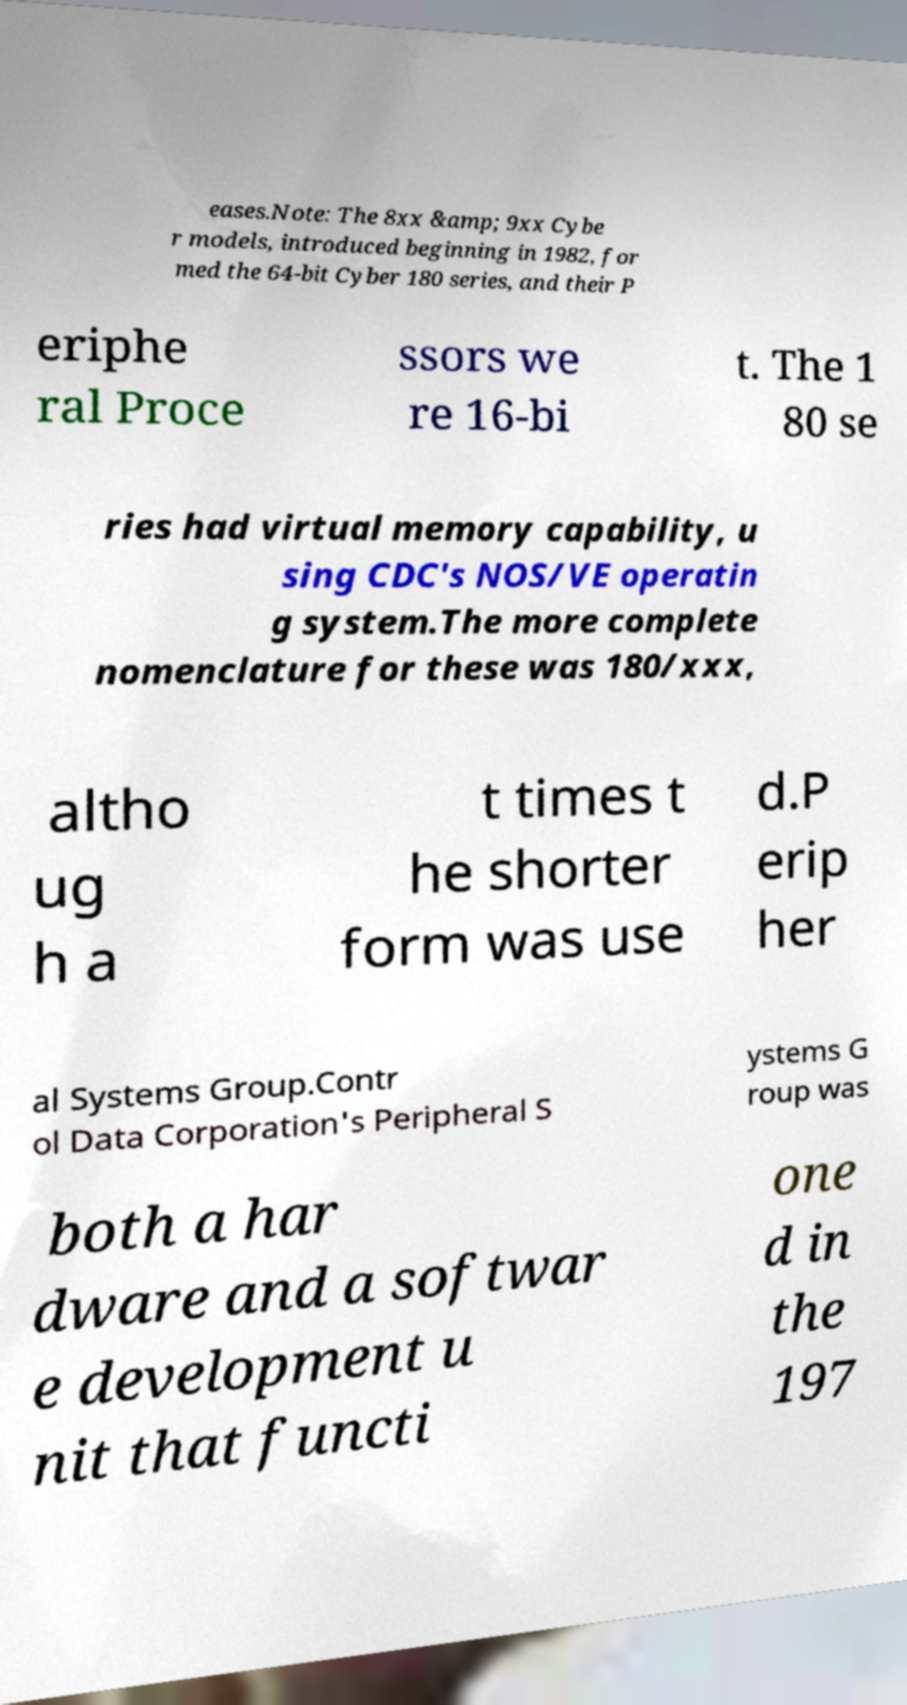For documentation purposes, I need the text within this image transcribed. Could you provide that? eases.Note: The 8xx &amp; 9xx Cybe r models, introduced beginning in 1982, for med the 64-bit Cyber 180 series, and their P eriphe ral Proce ssors we re 16-bi t. The 1 80 se ries had virtual memory capability, u sing CDC's NOS/VE operatin g system.The more complete nomenclature for these was 180/xxx, altho ug h a t times t he shorter form was use d.P erip her al Systems Group.Contr ol Data Corporation's Peripheral S ystems G roup was both a har dware and a softwar e development u nit that functi one d in the 197 